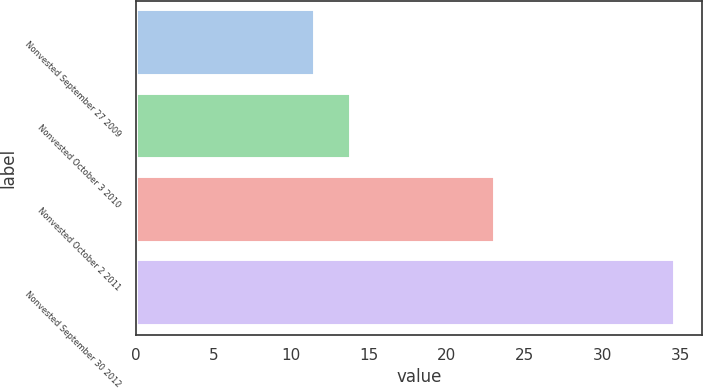<chart> <loc_0><loc_0><loc_500><loc_500><bar_chart><fcel>Nonvested September 27 2009<fcel>Nonvested October 3 2010<fcel>Nonvested October 2 2011<fcel>Nonvested September 30 2012<nl><fcel>11.55<fcel>13.86<fcel>23.11<fcel>34.68<nl></chart> 